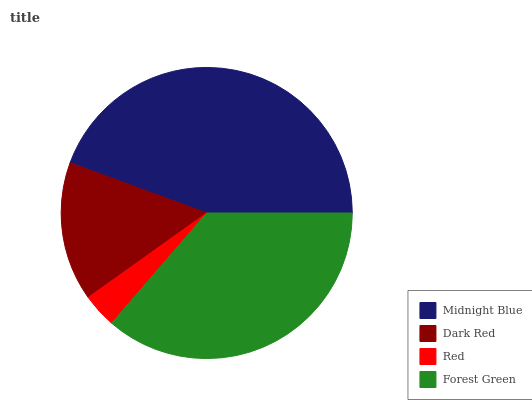Is Red the minimum?
Answer yes or no. Yes. Is Midnight Blue the maximum?
Answer yes or no. Yes. Is Dark Red the minimum?
Answer yes or no. No. Is Dark Red the maximum?
Answer yes or no. No. Is Midnight Blue greater than Dark Red?
Answer yes or no. Yes. Is Dark Red less than Midnight Blue?
Answer yes or no. Yes. Is Dark Red greater than Midnight Blue?
Answer yes or no. No. Is Midnight Blue less than Dark Red?
Answer yes or no. No. Is Forest Green the high median?
Answer yes or no. Yes. Is Dark Red the low median?
Answer yes or no. Yes. Is Midnight Blue the high median?
Answer yes or no. No. Is Midnight Blue the low median?
Answer yes or no. No. 